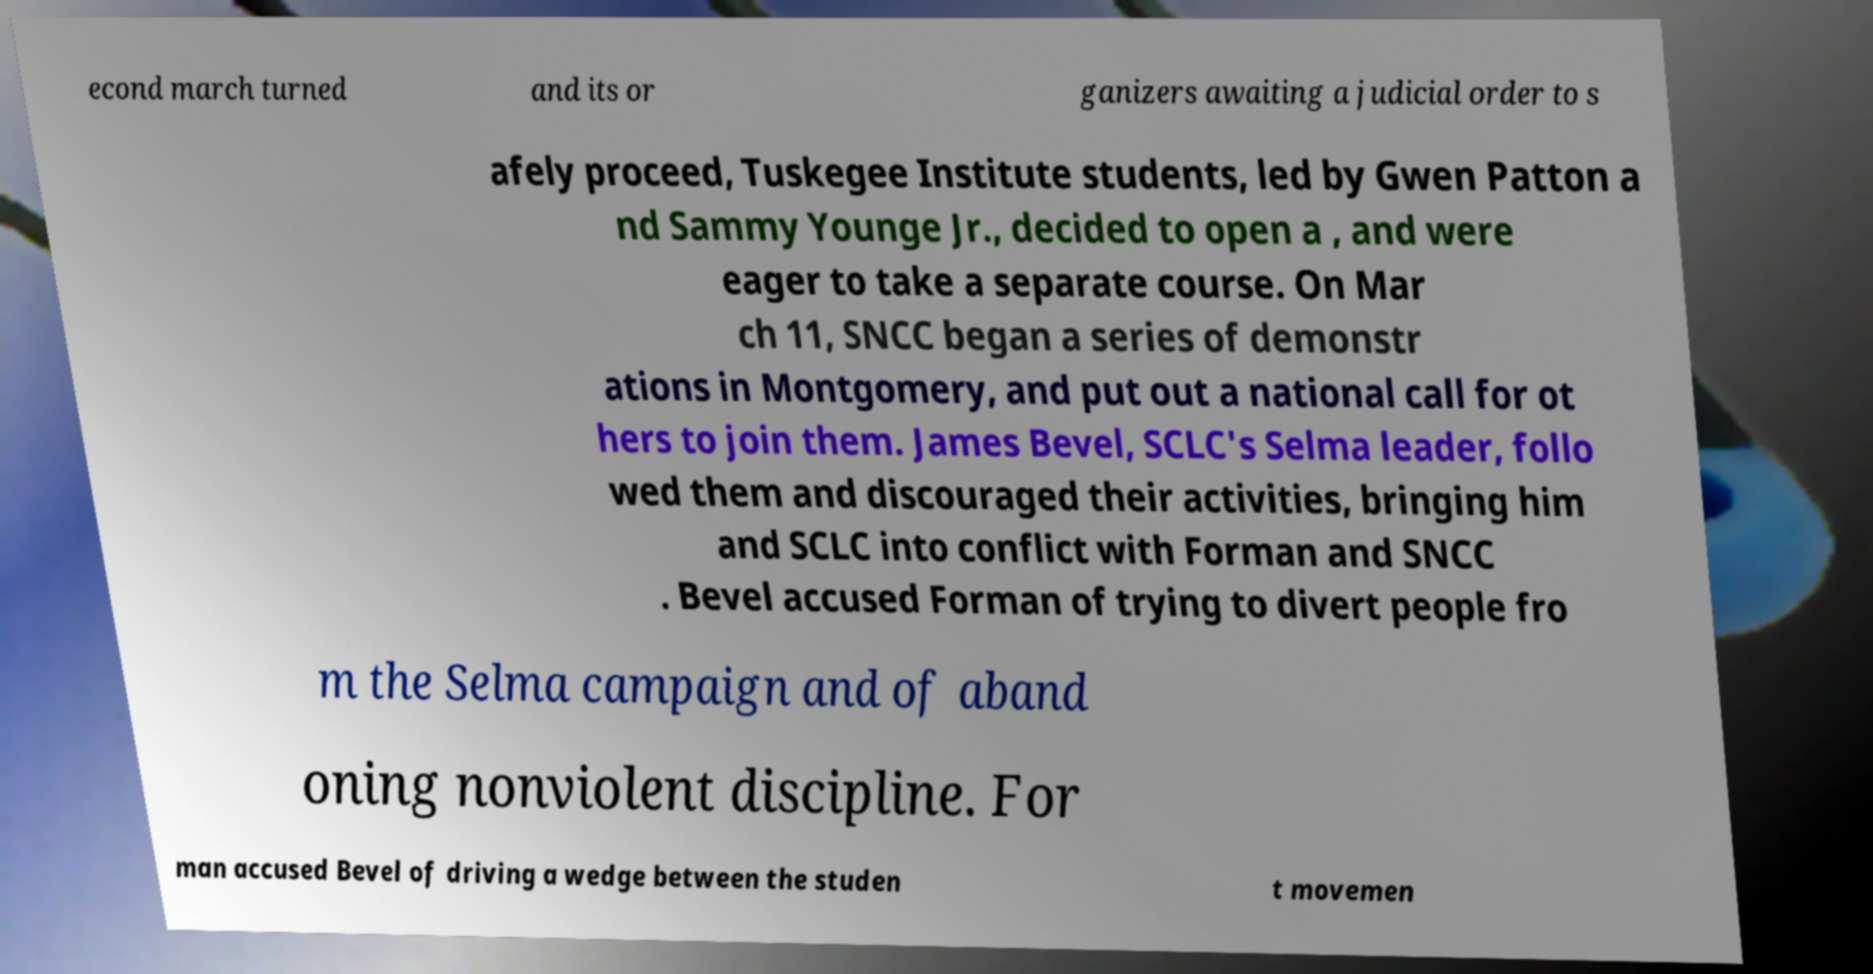There's text embedded in this image that I need extracted. Can you transcribe it verbatim? econd march turned and its or ganizers awaiting a judicial order to s afely proceed, Tuskegee Institute students, led by Gwen Patton a nd Sammy Younge Jr., decided to open a , and were eager to take a separate course. On Mar ch 11, SNCC began a series of demonstr ations in Montgomery, and put out a national call for ot hers to join them. James Bevel, SCLC's Selma leader, follo wed them and discouraged their activities, bringing him and SCLC into conflict with Forman and SNCC . Bevel accused Forman of trying to divert people fro m the Selma campaign and of aband oning nonviolent discipline. For man accused Bevel of driving a wedge between the studen t movemen 